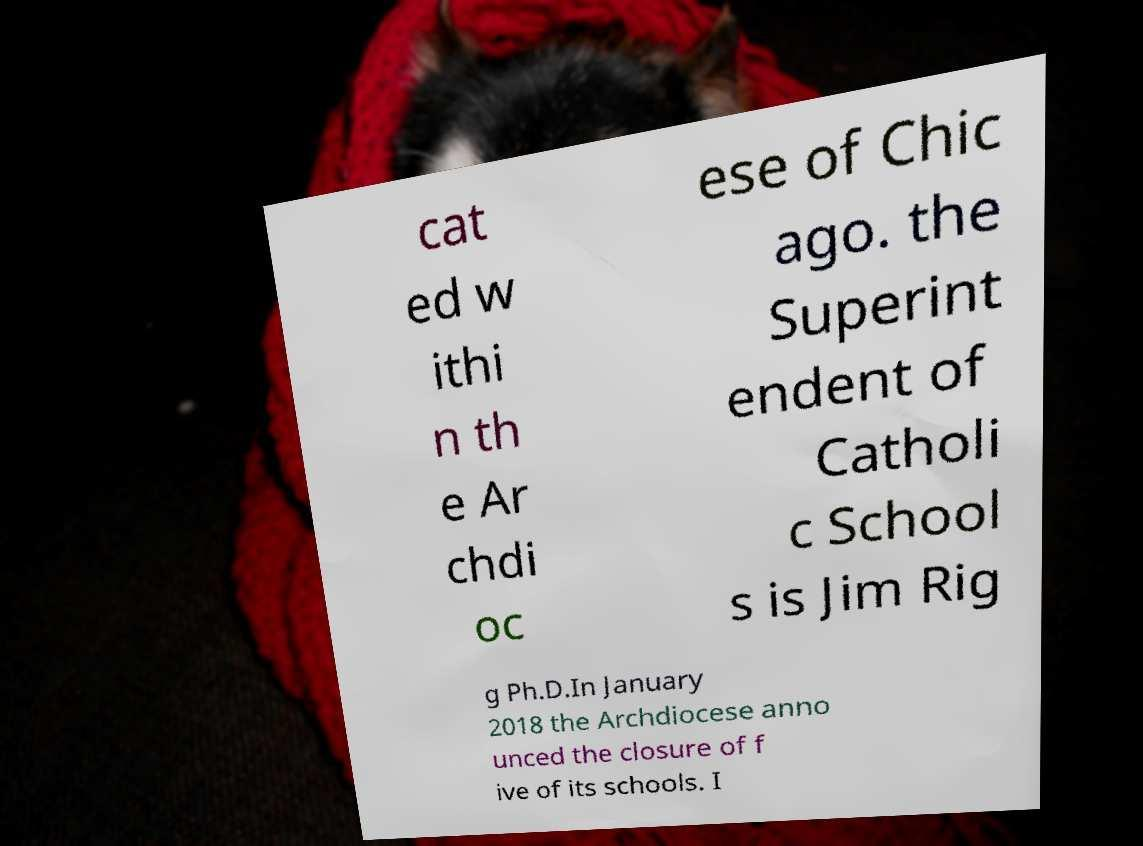Can you accurately transcribe the text from the provided image for me? cat ed w ithi n th e Ar chdi oc ese of Chic ago. the Superint endent of Catholi c School s is Jim Rig g Ph.D.In January 2018 the Archdiocese anno unced the closure of f ive of its schools. I 